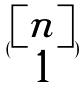<formula> <loc_0><loc_0><loc_500><loc_500>( \begin{matrix} [ n ] \\ 1 \end{matrix} )</formula> 